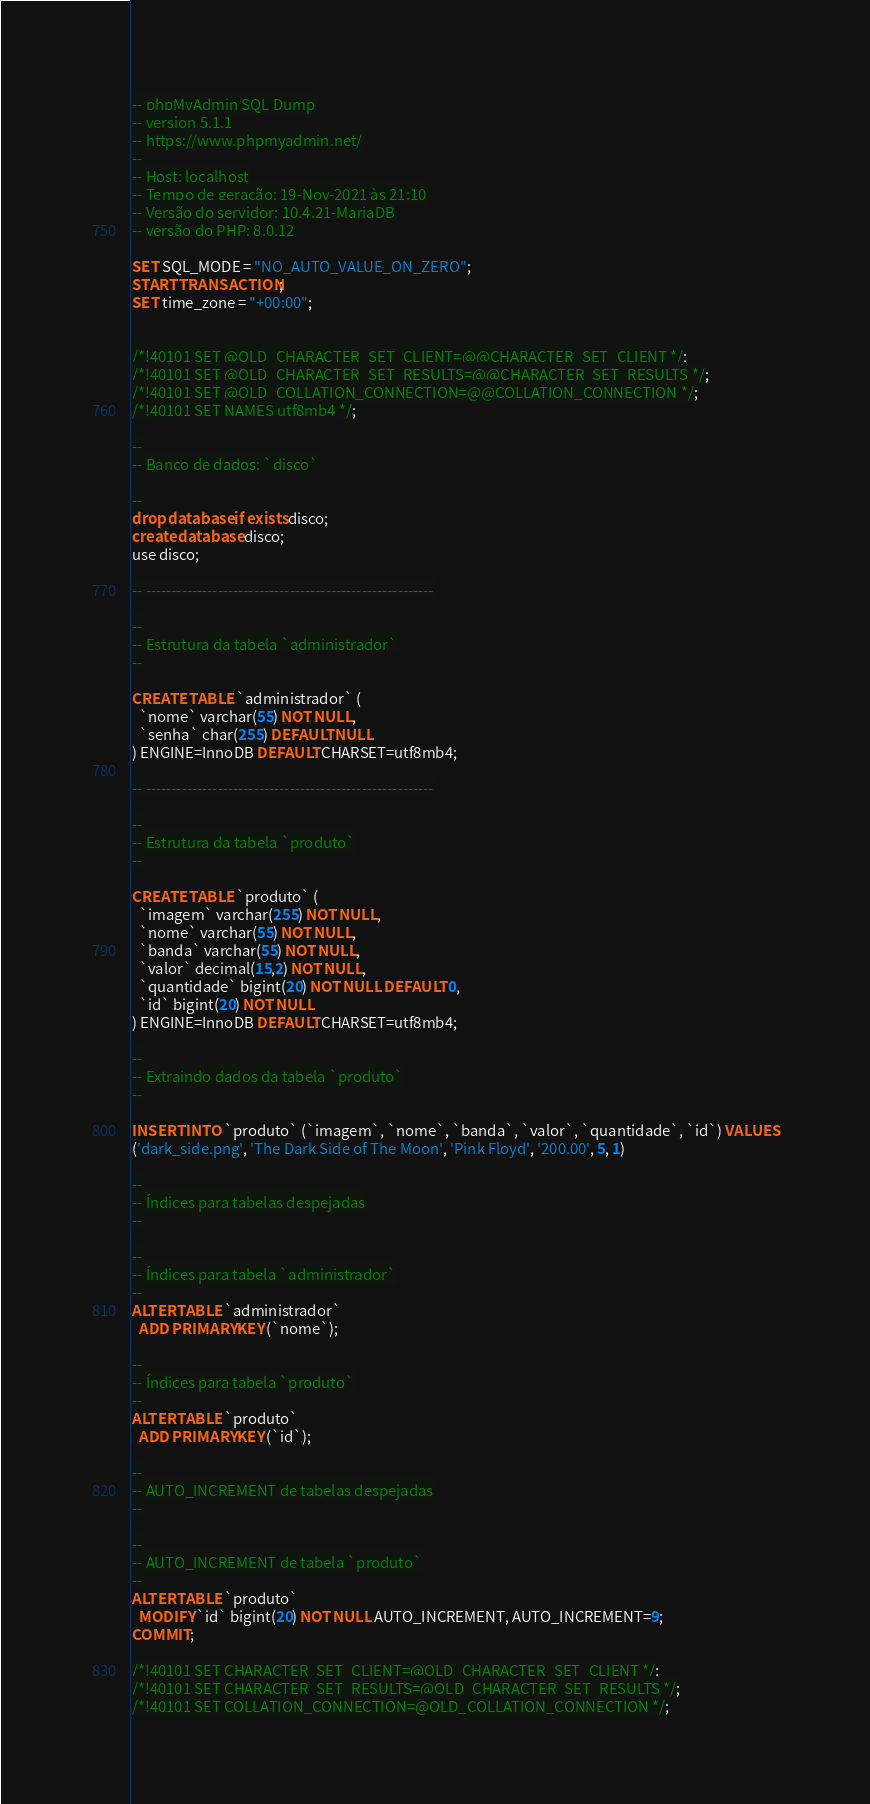<code> <loc_0><loc_0><loc_500><loc_500><_SQL_>-- phpMyAdmin SQL Dump
-- version 5.1.1
-- https://www.phpmyadmin.net/
--
-- Host: localhost
-- Tempo de geração: 19-Nov-2021 às 21:10
-- Versão do servidor: 10.4.21-MariaDB
-- versão do PHP: 8.0.12

SET SQL_MODE = "NO_AUTO_VALUE_ON_ZERO";
START TRANSACTION;
SET time_zone = "+00:00";


/*!40101 SET @OLD_CHARACTER_SET_CLIENT=@@CHARACTER_SET_CLIENT */;
/*!40101 SET @OLD_CHARACTER_SET_RESULTS=@@CHARACTER_SET_RESULTS */;
/*!40101 SET @OLD_COLLATION_CONNECTION=@@COLLATION_CONNECTION */;
/*!40101 SET NAMES utf8mb4 */;

--
-- Banco de dados: `disco`

--
drop database if exists disco;
create database disco;
use disco;

-- --------------------------------------------------------

--
-- Estrutura da tabela `administrador`
--

CREATE TABLE `administrador` (
  `nome` varchar(55) NOT NULL,
  `senha` char(255) DEFAULT NULL
) ENGINE=InnoDB DEFAULT CHARSET=utf8mb4;

-- --------------------------------------------------------

--
-- Estrutura da tabela `produto`
--

CREATE TABLE `produto` (
  `imagem` varchar(255) NOT NULL,
  `nome` varchar(55) NOT NULL,
  `banda` varchar(55) NOT NULL,
  `valor` decimal(15,2) NOT NULL,
  `quantidade` bigint(20) NOT NULL DEFAULT 0,
  `id` bigint(20) NOT NULL
) ENGINE=InnoDB DEFAULT CHARSET=utf8mb4;

--
-- Extraindo dados da tabela `produto`
--

INSERT INTO `produto` (`imagem`, `nome`, `banda`, `valor`, `quantidade`, `id`) VALUES
('dark_side.png', 'The Dark Side of The Moon', 'Pink Floyd', '200.00', 5, 1)

--
-- Índices para tabelas despejadas
--

--
-- Índices para tabela `administrador`
--
ALTER TABLE `administrador`
  ADD PRIMARY KEY (`nome`);

--
-- Índices para tabela `produto`
--
ALTER TABLE `produto`
  ADD PRIMARY KEY (`id`);

--
-- AUTO_INCREMENT de tabelas despejadas
--

--
-- AUTO_INCREMENT de tabela `produto`
--
ALTER TABLE `produto`
  MODIFY `id` bigint(20) NOT NULL AUTO_INCREMENT, AUTO_INCREMENT=9;
COMMIT;

/*!40101 SET CHARACTER_SET_CLIENT=@OLD_CHARACTER_SET_CLIENT */;
/*!40101 SET CHARACTER_SET_RESULTS=@OLD_CHARACTER_SET_RESULTS */;
/*!40101 SET COLLATION_CONNECTION=@OLD_COLLATION_CONNECTION */;
</code> 